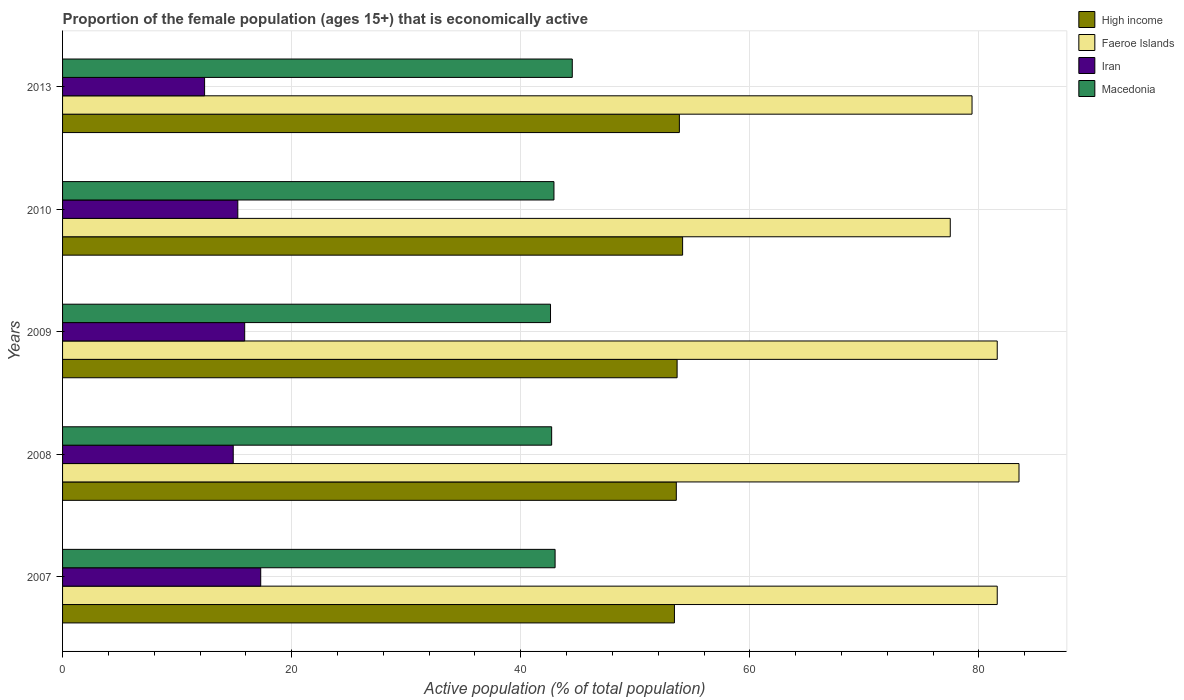How many groups of bars are there?
Your answer should be compact. 5. Are the number of bars per tick equal to the number of legend labels?
Provide a short and direct response. Yes. What is the label of the 2nd group of bars from the top?
Provide a succinct answer. 2010. In how many cases, is the number of bars for a given year not equal to the number of legend labels?
Give a very brief answer. 0. What is the proportion of the female population that is economically active in Macedonia in 2010?
Give a very brief answer. 42.9. Across all years, what is the maximum proportion of the female population that is economically active in Faeroe Islands?
Your answer should be compact. 83.5. Across all years, what is the minimum proportion of the female population that is economically active in Macedonia?
Offer a terse response. 42.6. What is the total proportion of the female population that is economically active in Faeroe Islands in the graph?
Offer a very short reply. 403.6. What is the difference between the proportion of the female population that is economically active in High income in 2007 and that in 2008?
Keep it short and to the point. -0.16. What is the difference between the proportion of the female population that is economically active in Faeroe Islands in 2008 and the proportion of the female population that is economically active in Iran in 2007?
Your response must be concise. 66.2. What is the average proportion of the female population that is economically active in Iran per year?
Ensure brevity in your answer.  15.16. In the year 2013, what is the difference between the proportion of the female population that is economically active in Macedonia and proportion of the female population that is economically active in Faeroe Islands?
Provide a succinct answer. -34.9. In how many years, is the proportion of the female population that is economically active in High income greater than 60 %?
Make the answer very short. 0. What is the ratio of the proportion of the female population that is economically active in High income in 2010 to that in 2013?
Your answer should be very brief. 1.01. Is the proportion of the female population that is economically active in High income in 2008 less than that in 2009?
Give a very brief answer. Yes. What is the difference between the highest and the second highest proportion of the female population that is economically active in Iran?
Your answer should be very brief. 1.4. What is the difference between the highest and the lowest proportion of the female population that is economically active in High income?
Ensure brevity in your answer.  0.71. In how many years, is the proportion of the female population that is economically active in Faeroe Islands greater than the average proportion of the female population that is economically active in Faeroe Islands taken over all years?
Your response must be concise. 3. What does the 4th bar from the top in 2010 represents?
Offer a very short reply. High income. What does the 2nd bar from the bottom in 2010 represents?
Ensure brevity in your answer.  Faeroe Islands. How many legend labels are there?
Offer a terse response. 4. What is the title of the graph?
Give a very brief answer. Proportion of the female population (ages 15+) that is economically active. Does "Central Europe" appear as one of the legend labels in the graph?
Make the answer very short. No. What is the label or title of the X-axis?
Give a very brief answer. Active population (% of total population). What is the label or title of the Y-axis?
Offer a very short reply. Years. What is the Active population (% of total population) of High income in 2007?
Your answer should be compact. 53.42. What is the Active population (% of total population) of Faeroe Islands in 2007?
Give a very brief answer. 81.6. What is the Active population (% of total population) of Iran in 2007?
Provide a short and direct response. 17.3. What is the Active population (% of total population) in High income in 2008?
Provide a succinct answer. 53.58. What is the Active population (% of total population) of Faeroe Islands in 2008?
Your answer should be compact. 83.5. What is the Active population (% of total population) of Iran in 2008?
Your answer should be very brief. 14.9. What is the Active population (% of total population) of Macedonia in 2008?
Your answer should be very brief. 42.7. What is the Active population (% of total population) of High income in 2009?
Offer a terse response. 53.65. What is the Active population (% of total population) in Faeroe Islands in 2009?
Provide a short and direct response. 81.6. What is the Active population (% of total population) of Iran in 2009?
Your answer should be very brief. 15.9. What is the Active population (% of total population) in Macedonia in 2009?
Your answer should be very brief. 42.6. What is the Active population (% of total population) in High income in 2010?
Make the answer very short. 54.13. What is the Active population (% of total population) in Faeroe Islands in 2010?
Your answer should be very brief. 77.5. What is the Active population (% of total population) in Iran in 2010?
Your response must be concise. 15.3. What is the Active population (% of total population) of Macedonia in 2010?
Your answer should be compact. 42.9. What is the Active population (% of total population) in High income in 2013?
Make the answer very short. 53.85. What is the Active population (% of total population) of Faeroe Islands in 2013?
Your response must be concise. 79.4. What is the Active population (% of total population) in Iran in 2013?
Give a very brief answer. 12.4. What is the Active population (% of total population) of Macedonia in 2013?
Your response must be concise. 44.5. Across all years, what is the maximum Active population (% of total population) in High income?
Give a very brief answer. 54.13. Across all years, what is the maximum Active population (% of total population) in Faeroe Islands?
Offer a terse response. 83.5. Across all years, what is the maximum Active population (% of total population) of Iran?
Your answer should be very brief. 17.3. Across all years, what is the maximum Active population (% of total population) of Macedonia?
Provide a short and direct response. 44.5. Across all years, what is the minimum Active population (% of total population) of High income?
Give a very brief answer. 53.42. Across all years, what is the minimum Active population (% of total population) of Faeroe Islands?
Your answer should be compact. 77.5. Across all years, what is the minimum Active population (% of total population) of Iran?
Make the answer very short. 12.4. Across all years, what is the minimum Active population (% of total population) of Macedonia?
Make the answer very short. 42.6. What is the total Active population (% of total population) of High income in the graph?
Your answer should be compact. 268.63. What is the total Active population (% of total population) in Faeroe Islands in the graph?
Provide a short and direct response. 403.6. What is the total Active population (% of total population) in Iran in the graph?
Your answer should be very brief. 75.8. What is the total Active population (% of total population) in Macedonia in the graph?
Give a very brief answer. 215.7. What is the difference between the Active population (% of total population) in High income in 2007 and that in 2008?
Your response must be concise. -0.16. What is the difference between the Active population (% of total population) in Macedonia in 2007 and that in 2008?
Keep it short and to the point. 0.3. What is the difference between the Active population (% of total population) in High income in 2007 and that in 2009?
Offer a very short reply. -0.23. What is the difference between the Active population (% of total population) in Iran in 2007 and that in 2009?
Keep it short and to the point. 1.4. What is the difference between the Active population (% of total population) of Macedonia in 2007 and that in 2009?
Your answer should be very brief. 0.4. What is the difference between the Active population (% of total population) of High income in 2007 and that in 2010?
Your response must be concise. -0.71. What is the difference between the Active population (% of total population) in High income in 2007 and that in 2013?
Ensure brevity in your answer.  -0.43. What is the difference between the Active population (% of total population) in Macedonia in 2007 and that in 2013?
Your answer should be compact. -1.5. What is the difference between the Active population (% of total population) in High income in 2008 and that in 2009?
Give a very brief answer. -0.07. What is the difference between the Active population (% of total population) in Iran in 2008 and that in 2009?
Provide a short and direct response. -1. What is the difference between the Active population (% of total population) of High income in 2008 and that in 2010?
Offer a terse response. -0.55. What is the difference between the Active population (% of total population) of Iran in 2008 and that in 2010?
Make the answer very short. -0.4. What is the difference between the Active population (% of total population) in High income in 2008 and that in 2013?
Offer a terse response. -0.27. What is the difference between the Active population (% of total population) of Iran in 2008 and that in 2013?
Offer a very short reply. 2.5. What is the difference between the Active population (% of total population) in High income in 2009 and that in 2010?
Keep it short and to the point. -0.48. What is the difference between the Active population (% of total population) of Iran in 2009 and that in 2010?
Ensure brevity in your answer.  0.6. What is the difference between the Active population (% of total population) in Macedonia in 2009 and that in 2010?
Keep it short and to the point. -0.3. What is the difference between the Active population (% of total population) in High income in 2009 and that in 2013?
Your answer should be very brief. -0.2. What is the difference between the Active population (% of total population) in Iran in 2009 and that in 2013?
Keep it short and to the point. 3.5. What is the difference between the Active population (% of total population) in Macedonia in 2009 and that in 2013?
Offer a terse response. -1.9. What is the difference between the Active population (% of total population) of High income in 2010 and that in 2013?
Provide a succinct answer. 0.28. What is the difference between the Active population (% of total population) in Faeroe Islands in 2010 and that in 2013?
Your answer should be very brief. -1.9. What is the difference between the Active population (% of total population) in Iran in 2010 and that in 2013?
Your response must be concise. 2.9. What is the difference between the Active population (% of total population) of High income in 2007 and the Active population (% of total population) of Faeroe Islands in 2008?
Provide a succinct answer. -30.08. What is the difference between the Active population (% of total population) of High income in 2007 and the Active population (% of total population) of Iran in 2008?
Your answer should be very brief. 38.52. What is the difference between the Active population (% of total population) in High income in 2007 and the Active population (% of total population) in Macedonia in 2008?
Your response must be concise. 10.72. What is the difference between the Active population (% of total population) in Faeroe Islands in 2007 and the Active population (% of total population) in Iran in 2008?
Provide a succinct answer. 66.7. What is the difference between the Active population (% of total population) of Faeroe Islands in 2007 and the Active population (% of total population) of Macedonia in 2008?
Provide a succinct answer. 38.9. What is the difference between the Active population (% of total population) in Iran in 2007 and the Active population (% of total population) in Macedonia in 2008?
Keep it short and to the point. -25.4. What is the difference between the Active population (% of total population) of High income in 2007 and the Active population (% of total population) of Faeroe Islands in 2009?
Keep it short and to the point. -28.18. What is the difference between the Active population (% of total population) of High income in 2007 and the Active population (% of total population) of Iran in 2009?
Provide a short and direct response. 37.52. What is the difference between the Active population (% of total population) of High income in 2007 and the Active population (% of total population) of Macedonia in 2009?
Ensure brevity in your answer.  10.82. What is the difference between the Active population (% of total population) of Faeroe Islands in 2007 and the Active population (% of total population) of Iran in 2009?
Provide a succinct answer. 65.7. What is the difference between the Active population (% of total population) of Faeroe Islands in 2007 and the Active population (% of total population) of Macedonia in 2009?
Provide a succinct answer. 39. What is the difference between the Active population (% of total population) in Iran in 2007 and the Active population (% of total population) in Macedonia in 2009?
Keep it short and to the point. -25.3. What is the difference between the Active population (% of total population) in High income in 2007 and the Active population (% of total population) in Faeroe Islands in 2010?
Give a very brief answer. -24.08. What is the difference between the Active population (% of total population) of High income in 2007 and the Active population (% of total population) of Iran in 2010?
Make the answer very short. 38.12. What is the difference between the Active population (% of total population) of High income in 2007 and the Active population (% of total population) of Macedonia in 2010?
Make the answer very short. 10.52. What is the difference between the Active population (% of total population) of Faeroe Islands in 2007 and the Active population (% of total population) of Iran in 2010?
Your response must be concise. 66.3. What is the difference between the Active population (% of total population) of Faeroe Islands in 2007 and the Active population (% of total population) of Macedonia in 2010?
Provide a succinct answer. 38.7. What is the difference between the Active population (% of total population) in Iran in 2007 and the Active population (% of total population) in Macedonia in 2010?
Keep it short and to the point. -25.6. What is the difference between the Active population (% of total population) of High income in 2007 and the Active population (% of total population) of Faeroe Islands in 2013?
Your answer should be very brief. -25.98. What is the difference between the Active population (% of total population) in High income in 2007 and the Active population (% of total population) in Iran in 2013?
Ensure brevity in your answer.  41.02. What is the difference between the Active population (% of total population) of High income in 2007 and the Active population (% of total population) of Macedonia in 2013?
Provide a short and direct response. 8.92. What is the difference between the Active population (% of total population) of Faeroe Islands in 2007 and the Active population (% of total population) of Iran in 2013?
Provide a short and direct response. 69.2. What is the difference between the Active population (% of total population) of Faeroe Islands in 2007 and the Active population (% of total population) of Macedonia in 2013?
Offer a terse response. 37.1. What is the difference between the Active population (% of total population) of Iran in 2007 and the Active population (% of total population) of Macedonia in 2013?
Offer a terse response. -27.2. What is the difference between the Active population (% of total population) of High income in 2008 and the Active population (% of total population) of Faeroe Islands in 2009?
Make the answer very short. -28.02. What is the difference between the Active population (% of total population) in High income in 2008 and the Active population (% of total population) in Iran in 2009?
Ensure brevity in your answer.  37.68. What is the difference between the Active population (% of total population) in High income in 2008 and the Active population (% of total population) in Macedonia in 2009?
Ensure brevity in your answer.  10.98. What is the difference between the Active population (% of total population) of Faeroe Islands in 2008 and the Active population (% of total population) of Iran in 2009?
Give a very brief answer. 67.6. What is the difference between the Active population (% of total population) of Faeroe Islands in 2008 and the Active population (% of total population) of Macedonia in 2009?
Offer a very short reply. 40.9. What is the difference between the Active population (% of total population) in Iran in 2008 and the Active population (% of total population) in Macedonia in 2009?
Offer a very short reply. -27.7. What is the difference between the Active population (% of total population) in High income in 2008 and the Active population (% of total population) in Faeroe Islands in 2010?
Your response must be concise. -23.92. What is the difference between the Active population (% of total population) in High income in 2008 and the Active population (% of total population) in Iran in 2010?
Offer a terse response. 38.28. What is the difference between the Active population (% of total population) of High income in 2008 and the Active population (% of total population) of Macedonia in 2010?
Your answer should be compact. 10.68. What is the difference between the Active population (% of total population) of Faeroe Islands in 2008 and the Active population (% of total population) of Iran in 2010?
Your answer should be very brief. 68.2. What is the difference between the Active population (% of total population) in Faeroe Islands in 2008 and the Active population (% of total population) in Macedonia in 2010?
Keep it short and to the point. 40.6. What is the difference between the Active population (% of total population) in High income in 2008 and the Active population (% of total population) in Faeroe Islands in 2013?
Make the answer very short. -25.82. What is the difference between the Active population (% of total population) of High income in 2008 and the Active population (% of total population) of Iran in 2013?
Ensure brevity in your answer.  41.18. What is the difference between the Active population (% of total population) in High income in 2008 and the Active population (% of total population) in Macedonia in 2013?
Your answer should be compact. 9.08. What is the difference between the Active population (% of total population) in Faeroe Islands in 2008 and the Active population (% of total population) in Iran in 2013?
Ensure brevity in your answer.  71.1. What is the difference between the Active population (% of total population) of Faeroe Islands in 2008 and the Active population (% of total population) of Macedonia in 2013?
Your answer should be compact. 39. What is the difference between the Active population (% of total population) in Iran in 2008 and the Active population (% of total population) in Macedonia in 2013?
Give a very brief answer. -29.6. What is the difference between the Active population (% of total population) of High income in 2009 and the Active population (% of total population) of Faeroe Islands in 2010?
Offer a very short reply. -23.85. What is the difference between the Active population (% of total population) of High income in 2009 and the Active population (% of total population) of Iran in 2010?
Ensure brevity in your answer.  38.35. What is the difference between the Active population (% of total population) in High income in 2009 and the Active population (% of total population) in Macedonia in 2010?
Offer a terse response. 10.75. What is the difference between the Active population (% of total population) in Faeroe Islands in 2009 and the Active population (% of total population) in Iran in 2010?
Provide a succinct answer. 66.3. What is the difference between the Active population (% of total population) of Faeroe Islands in 2009 and the Active population (% of total population) of Macedonia in 2010?
Provide a succinct answer. 38.7. What is the difference between the Active population (% of total population) in High income in 2009 and the Active population (% of total population) in Faeroe Islands in 2013?
Keep it short and to the point. -25.75. What is the difference between the Active population (% of total population) in High income in 2009 and the Active population (% of total population) in Iran in 2013?
Give a very brief answer. 41.25. What is the difference between the Active population (% of total population) in High income in 2009 and the Active population (% of total population) in Macedonia in 2013?
Your answer should be very brief. 9.15. What is the difference between the Active population (% of total population) of Faeroe Islands in 2009 and the Active population (% of total population) of Iran in 2013?
Your answer should be very brief. 69.2. What is the difference between the Active population (% of total population) in Faeroe Islands in 2009 and the Active population (% of total population) in Macedonia in 2013?
Your answer should be very brief. 37.1. What is the difference between the Active population (% of total population) of Iran in 2009 and the Active population (% of total population) of Macedonia in 2013?
Offer a terse response. -28.6. What is the difference between the Active population (% of total population) of High income in 2010 and the Active population (% of total population) of Faeroe Islands in 2013?
Make the answer very short. -25.27. What is the difference between the Active population (% of total population) of High income in 2010 and the Active population (% of total population) of Iran in 2013?
Provide a succinct answer. 41.73. What is the difference between the Active population (% of total population) in High income in 2010 and the Active population (% of total population) in Macedonia in 2013?
Ensure brevity in your answer.  9.63. What is the difference between the Active population (% of total population) in Faeroe Islands in 2010 and the Active population (% of total population) in Iran in 2013?
Make the answer very short. 65.1. What is the difference between the Active population (% of total population) in Faeroe Islands in 2010 and the Active population (% of total population) in Macedonia in 2013?
Offer a very short reply. 33. What is the difference between the Active population (% of total population) of Iran in 2010 and the Active population (% of total population) of Macedonia in 2013?
Make the answer very short. -29.2. What is the average Active population (% of total population) in High income per year?
Make the answer very short. 53.73. What is the average Active population (% of total population) in Faeroe Islands per year?
Your response must be concise. 80.72. What is the average Active population (% of total population) in Iran per year?
Offer a terse response. 15.16. What is the average Active population (% of total population) of Macedonia per year?
Give a very brief answer. 43.14. In the year 2007, what is the difference between the Active population (% of total population) of High income and Active population (% of total population) of Faeroe Islands?
Your answer should be very brief. -28.18. In the year 2007, what is the difference between the Active population (% of total population) of High income and Active population (% of total population) of Iran?
Offer a terse response. 36.12. In the year 2007, what is the difference between the Active population (% of total population) of High income and Active population (% of total population) of Macedonia?
Offer a very short reply. 10.42. In the year 2007, what is the difference between the Active population (% of total population) of Faeroe Islands and Active population (% of total population) of Iran?
Your answer should be compact. 64.3. In the year 2007, what is the difference between the Active population (% of total population) in Faeroe Islands and Active population (% of total population) in Macedonia?
Your answer should be very brief. 38.6. In the year 2007, what is the difference between the Active population (% of total population) in Iran and Active population (% of total population) in Macedonia?
Provide a short and direct response. -25.7. In the year 2008, what is the difference between the Active population (% of total population) in High income and Active population (% of total population) in Faeroe Islands?
Give a very brief answer. -29.92. In the year 2008, what is the difference between the Active population (% of total population) of High income and Active population (% of total population) of Iran?
Offer a very short reply. 38.68. In the year 2008, what is the difference between the Active population (% of total population) of High income and Active population (% of total population) of Macedonia?
Keep it short and to the point. 10.88. In the year 2008, what is the difference between the Active population (% of total population) in Faeroe Islands and Active population (% of total population) in Iran?
Offer a terse response. 68.6. In the year 2008, what is the difference between the Active population (% of total population) in Faeroe Islands and Active population (% of total population) in Macedonia?
Your response must be concise. 40.8. In the year 2008, what is the difference between the Active population (% of total population) of Iran and Active population (% of total population) of Macedonia?
Provide a succinct answer. -27.8. In the year 2009, what is the difference between the Active population (% of total population) in High income and Active population (% of total population) in Faeroe Islands?
Your answer should be very brief. -27.95. In the year 2009, what is the difference between the Active population (% of total population) of High income and Active population (% of total population) of Iran?
Offer a terse response. 37.75. In the year 2009, what is the difference between the Active population (% of total population) in High income and Active population (% of total population) in Macedonia?
Make the answer very short. 11.05. In the year 2009, what is the difference between the Active population (% of total population) in Faeroe Islands and Active population (% of total population) in Iran?
Ensure brevity in your answer.  65.7. In the year 2009, what is the difference between the Active population (% of total population) of Iran and Active population (% of total population) of Macedonia?
Your answer should be very brief. -26.7. In the year 2010, what is the difference between the Active population (% of total population) in High income and Active population (% of total population) in Faeroe Islands?
Your answer should be very brief. -23.37. In the year 2010, what is the difference between the Active population (% of total population) in High income and Active population (% of total population) in Iran?
Ensure brevity in your answer.  38.83. In the year 2010, what is the difference between the Active population (% of total population) in High income and Active population (% of total population) in Macedonia?
Your response must be concise. 11.23. In the year 2010, what is the difference between the Active population (% of total population) in Faeroe Islands and Active population (% of total population) in Iran?
Offer a very short reply. 62.2. In the year 2010, what is the difference between the Active population (% of total population) in Faeroe Islands and Active population (% of total population) in Macedonia?
Make the answer very short. 34.6. In the year 2010, what is the difference between the Active population (% of total population) in Iran and Active population (% of total population) in Macedonia?
Your answer should be very brief. -27.6. In the year 2013, what is the difference between the Active population (% of total population) of High income and Active population (% of total population) of Faeroe Islands?
Offer a terse response. -25.55. In the year 2013, what is the difference between the Active population (% of total population) in High income and Active population (% of total population) in Iran?
Provide a short and direct response. 41.45. In the year 2013, what is the difference between the Active population (% of total population) in High income and Active population (% of total population) in Macedonia?
Your answer should be very brief. 9.35. In the year 2013, what is the difference between the Active population (% of total population) in Faeroe Islands and Active population (% of total population) in Macedonia?
Your answer should be compact. 34.9. In the year 2013, what is the difference between the Active population (% of total population) in Iran and Active population (% of total population) in Macedonia?
Your answer should be very brief. -32.1. What is the ratio of the Active population (% of total population) in High income in 2007 to that in 2008?
Offer a very short reply. 1. What is the ratio of the Active population (% of total population) in Faeroe Islands in 2007 to that in 2008?
Your response must be concise. 0.98. What is the ratio of the Active population (% of total population) in Iran in 2007 to that in 2008?
Offer a terse response. 1.16. What is the ratio of the Active population (% of total population) of Iran in 2007 to that in 2009?
Offer a terse response. 1.09. What is the ratio of the Active population (% of total population) of Macedonia in 2007 to that in 2009?
Provide a short and direct response. 1.01. What is the ratio of the Active population (% of total population) of High income in 2007 to that in 2010?
Offer a terse response. 0.99. What is the ratio of the Active population (% of total population) of Faeroe Islands in 2007 to that in 2010?
Give a very brief answer. 1.05. What is the ratio of the Active population (% of total population) in Iran in 2007 to that in 2010?
Your answer should be very brief. 1.13. What is the ratio of the Active population (% of total population) of Faeroe Islands in 2007 to that in 2013?
Ensure brevity in your answer.  1.03. What is the ratio of the Active population (% of total population) in Iran in 2007 to that in 2013?
Make the answer very short. 1.4. What is the ratio of the Active population (% of total population) of Macedonia in 2007 to that in 2013?
Your response must be concise. 0.97. What is the ratio of the Active population (% of total population) in Faeroe Islands in 2008 to that in 2009?
Your answer should be very brief. 1.02. What is the ratio of the Active population (% of total population) of Iran in 2008 to that in 2009?
Give a very brief answer. 0.94. What is the ratio of the Active population (% of total population) in Macedonia in 2008 to that in 2009?
Provide a succinct answer. 1. What is the ratio of the Active population (% of total population) in High income in 2008 to that in 2010?
Provide a short and direct response. 0.99. What is the ratio of the Active population (% of total population) in Faeroe Islands in 2008 to that in 2010?
Keep it short and to the point. 1.08. What is the ratio of the Active population (% of total population) of Iran in 2008 to that in 2010?
Offer a terse response. 0.97. What is the ratio of the Active population (% of total population) in Faeroe Islands in 2008 to that in 2013?
Offer a very short reply. 1.05. What is the ratio of the Active population (% of total population) of Iran in 2008 to that in 2013?
Make the answer very short. 1.2. What is the ratio of the Active population (% of total population) of Macedonia in 2008 to that in 2013?
Provide a succinct answer. 0.96. What is the ratio of the Active population (% of total population) in High income in 2009 to that in 2010?
Offer a terse response. 0.99. What is the ratio of the Active population (% of total population) of Faeroe Islands in 2009 to that in 2010?
Ensure brevity in your answer.  1.05. What is the ratio of the Active population (% of total population) of Iran in 2009 to that in 2010?
Give a very brief answer. 1.04. What is the ratio of the Active population (% of total population) in High income in 2009 to that in 2013?
Make the answer very short. 1. What is the ratio of the Active population (% of total population) in Faeroe Islands in 2009 to that in 2013?
Your answer should be very brief. 1.03. What is the ratio of the Active population (% of total population) in Iran in 2009 to that in 2013?
Offer a very short reply. 1.28. What is the ratio of the Active population (% of total population) in Macedonia in 2009 to that in 2013?
Provide a succinct answer. 0.96. What is the ratio of the Active population (% of total population) of High income in 2010 to that in 2013?
Your answer should be very brief. 1.01. What is the ratio of the Active population (% of total population) in Faeroe Islands in 2010 to that in 2013?
Give a very brief answer. 0.98. What is the ratio of the Active population (% of total population) of Iran in 2010 to that in 2013?
Your response must be concise. 1.23. What is the ratio of the Active population (% of total population) in Macedonia in 2010 to that in 2013?
Give a very brief answer. 0.96. What is the difference between the highest and the second highest Active population (% of total population) of High income?
Keep it short and to the point. 0.28. What is the difference between the highest and the second highest Active population (% of total population) in Faeroe Islands?
Keep it short and to the point. 1.9. What is the difference between the highest and the second highest Active population (% of total population) of Macedonia?
Provide a succinct answer. 1.5. What is the difference between the highest and the lowest Active population (% of total population) in High income?
Ensure brevity in your answer.  0.71. What is the difference between the highest and the lowest Active population (% of total population) of Faeroe Islands?
Offer a very short reply. 6. What is the difference between the highest and the lowest Active population (% of total population) in Iran?
Provide a succinct answer. 4.9. 